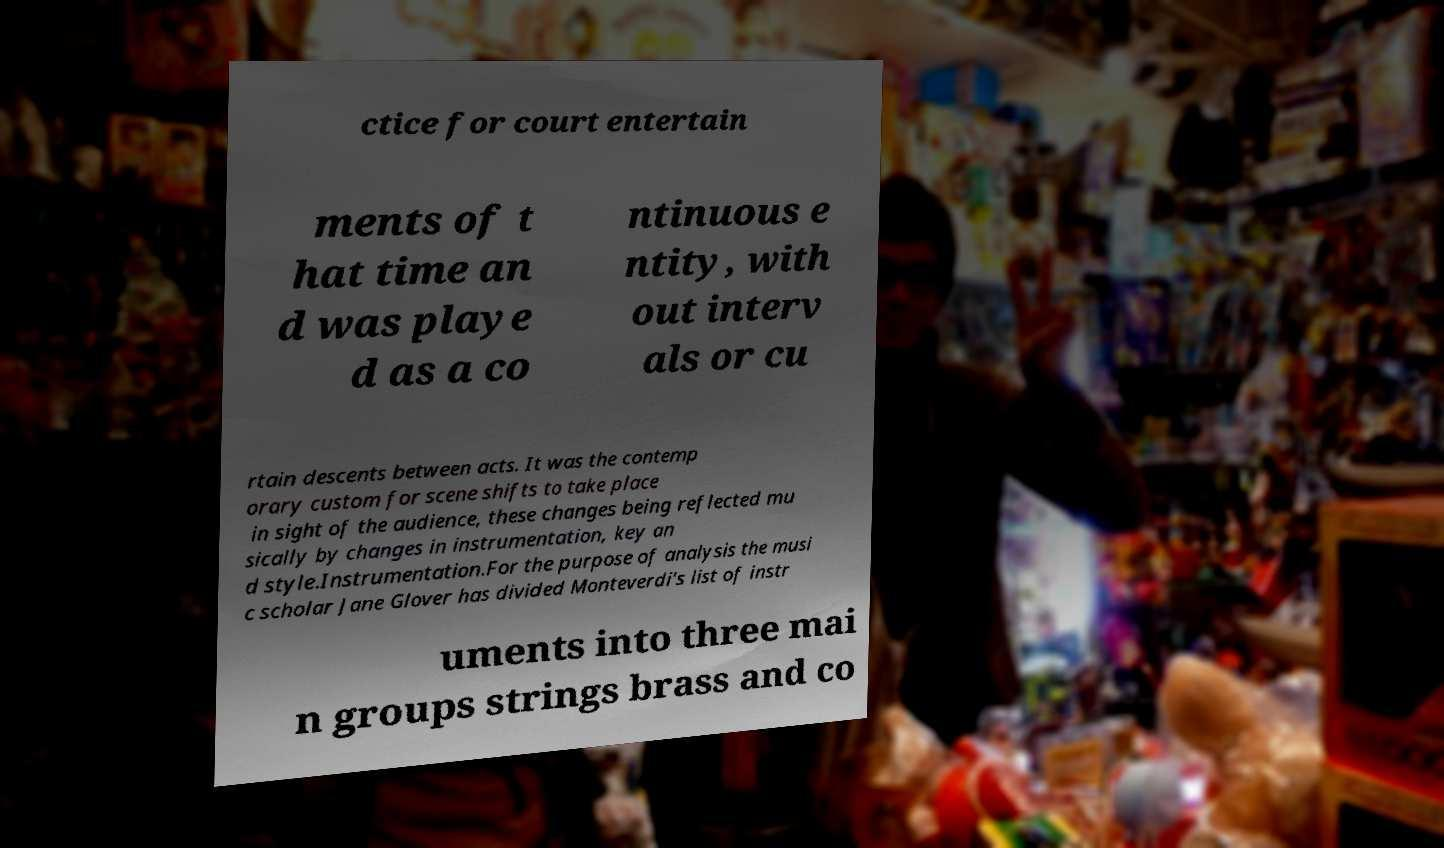For documentation purposes, I need the text within this image transcribed. Could you provide that? ctice for court entertain ments of t hat time an d was playe d as a co ntinuous e ntity, with out interv als or cu rtain descents between acts. It was the contemp orary custom for scene shifts to take place in sight of the audience, these changes being reflected mu sically by changes in instrumentation, key an d style.Instrumentation.For the purpose of analysis the musi c scholar Jane Glover has divided Monteverdi's list of instr uments into three mai n groups strings brass and co 